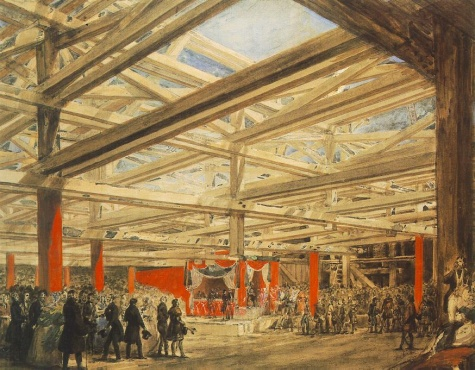Can you describe the attire of the people in the image? The individuals in the painting are dressed in varied, mostly formal attire that reflects a range of social statuses. Many men wear long coats and hats, indicative of 19th-century European fashion, while women are seen in dresses with some degree of embellishment. This assortment of clothing suggests a gathering that includes different classes, possibly during a significant event where various societal groups are represented. 